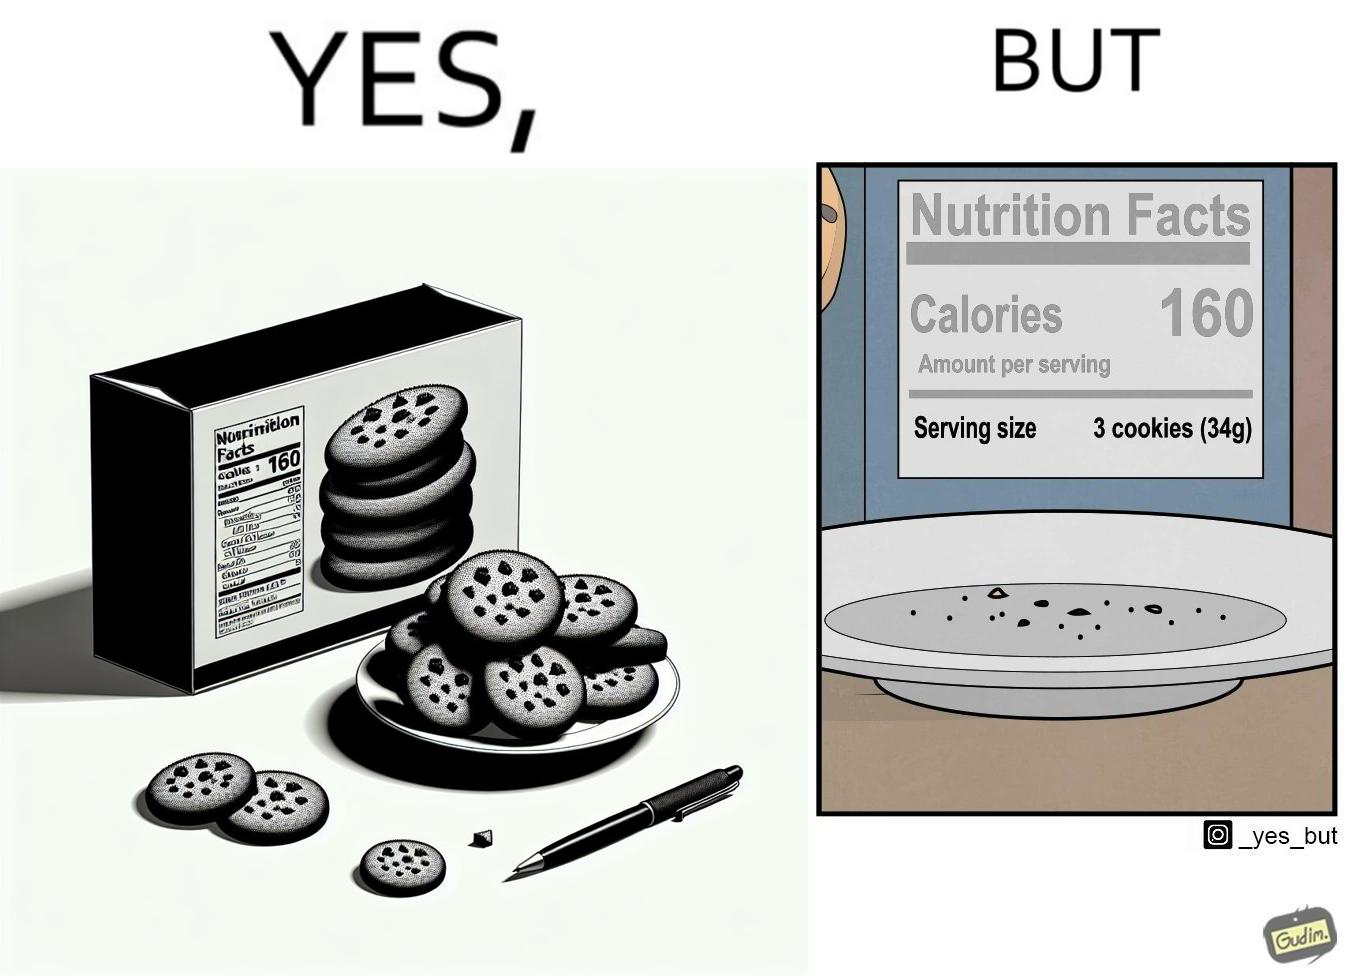Describe the content of this image. The image is funny because the full plate of cookies is hiding the entire nutrition facts leading readers to believe that the entire box of cookies amounts to just 160 calories but when all the cookies are eaten and the plate is empty, the rest of the nutrition table is visible which tells that each serving of cookies amounts to 160 calories where one serving consists of 3 cookies. 